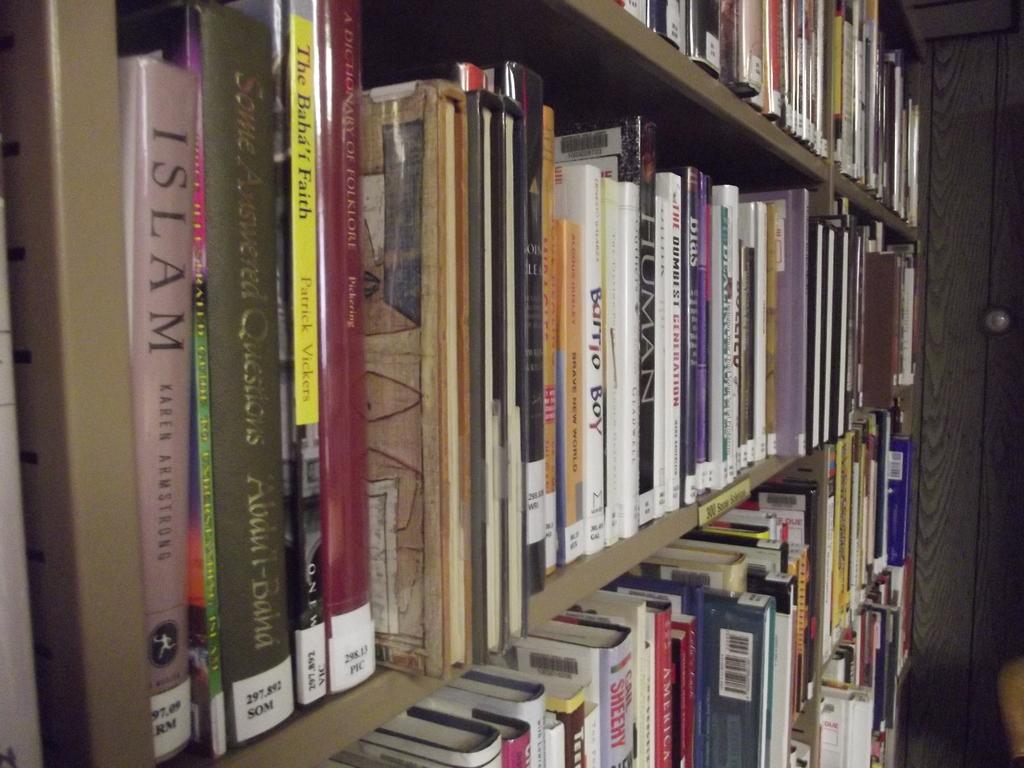What is the title of the book authored by karen armstrong?
Provide a succinct answer. Islam. 